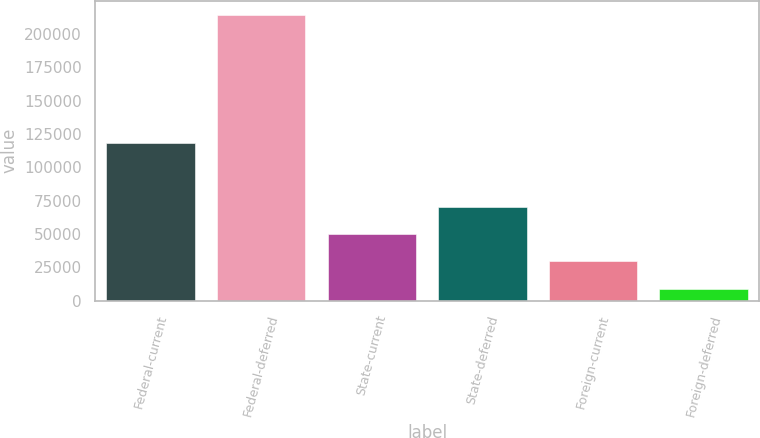Convert chart to OTSL. <chart><loc_0><loc_0><loc_500><loc_500><bar_chart><fcel>Federal-current<fcel>Federal-deferred<fcel>State-current<fcel>State-deferred<fcel>Foreign-current<fcel>Foreign-deferred<nl><fcel>118314<fcel>214132<fcel>49901.6<fcel>70430.4<fcel>29372.8<fcel>8844<nl></chart> 